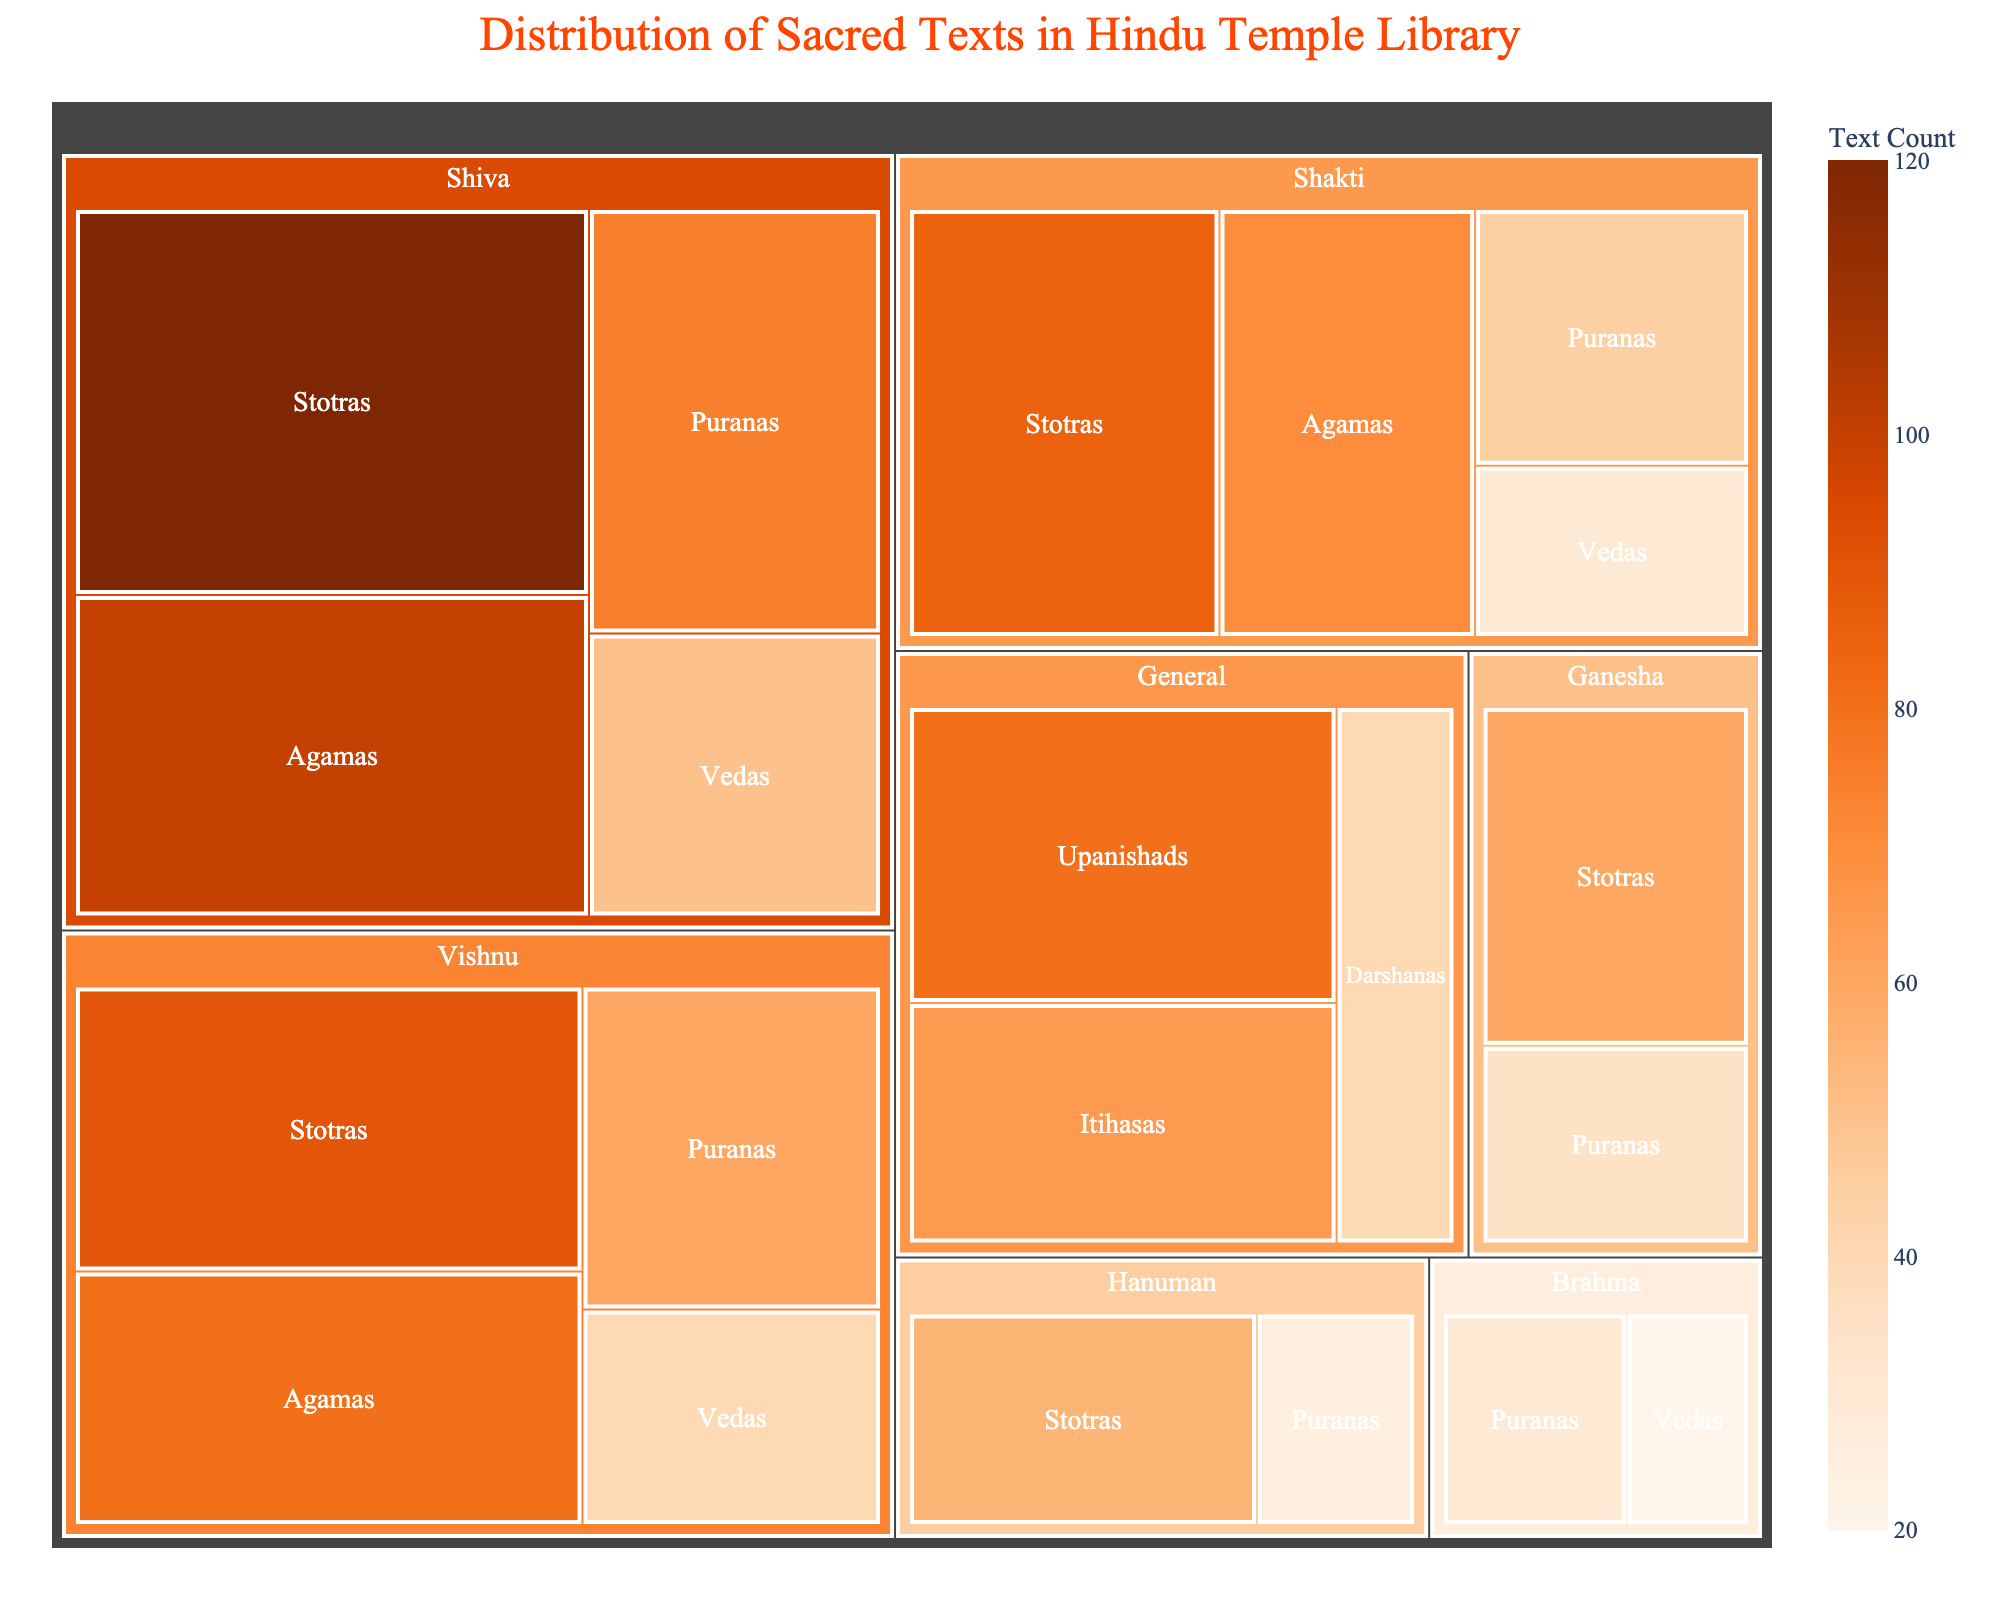Which deity has the most sacred texts overall? By examining the total size of the colored blocks in the treemap, the majority of the area corresponds to Shiva, indicating that he has the most sacred texts overall.
Answer: Shiva How many types of scriptures are listed for Vishnu? Vishnu's node in the treemap has four sub-categories representing the scripture types, which are Vedas, Puranas, Agamas, and Stotras.
Answer: 4 What is the total count of Puranas for all deities? Sum the counts for Puranas across all deities: Shiva (75) + Vishnu (60) + Shakti (45) + Ganesha (35) + Hanuman (25) + Brahma (30) = 270.
Answer: 270 Which scripture type related to Shakti has the highest count? Among the sub-categories under Shakti in the treemap, Stotras has the largest area, indicating the highest count.
Answer: Stotras Compare the count of Stotras between Shiva and Vishnu. Which one has more? Shiva has 120 Stotras, while Vishnu has 90 Stotras. Comparing these two, Shiva has more Stotras.
Answer: Shiva Is there any deity for which Vedas have the least count compared to other scripture types? By examining each deity's categories for Vedas, we see that Brahma has the least count of 20 for Vedas compared to other scripture types within Brahma's node.
Answer: Brahma What is the total count of Agamas for Shiva, Vishnu, and Shakti? Sum the counts of Agamas for Shiva (100), Vishnu (80), and Shakti (70): 100 + 80 + 70 = 250.
Answer: 250 Which scripture type has the highest count under 'General'? Under the 'General' node, Upanishads have the largest area, indicating the highest count of 80.
Answer: Upanishads 